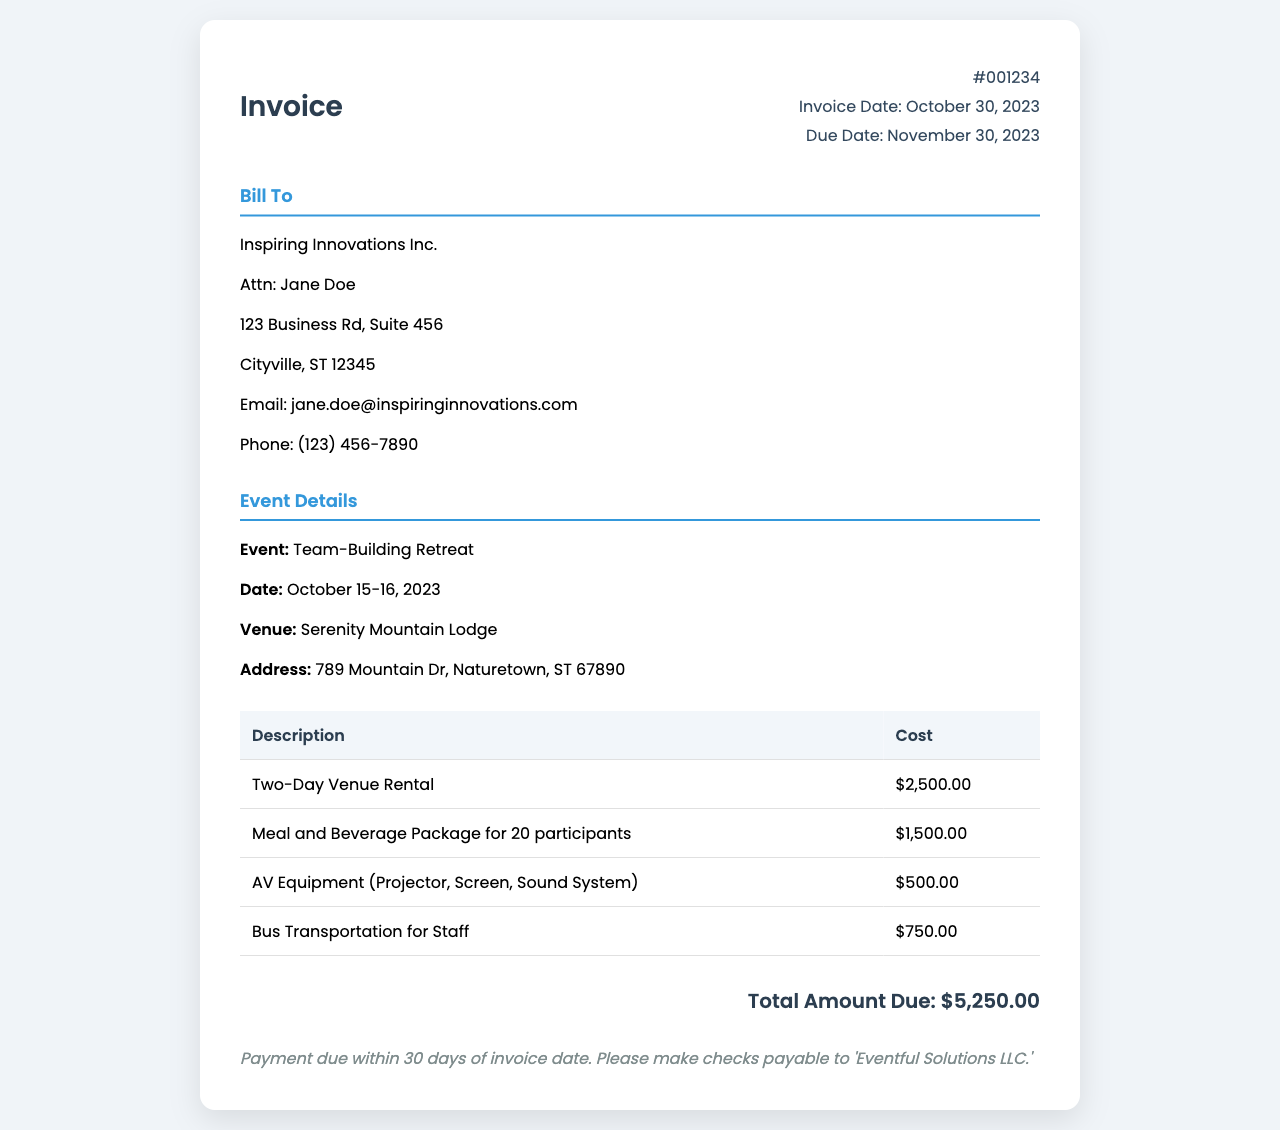what is the invoice number? The invoice number is listed at the top of the document under "Invoice Number."
Answer: #001234 who is the invoice billed to? The billing information includes the name of the company and contact person, found in the "Bill To" section.
Answer: Inspiring Innovations Inc what is the total amount due? The total amount due is prominently displayed at the bottom of the invoice.
Answer: $5,250.00 what are the dates of the event? The event dates are specified in the "Event Details" section.
Answer: October 15-16, 2023 where is the event venue located? The venue address is listed under "Event Details."
Answer: 789 Mountain Dr, Naturetown, ST 67890 how many participants were included in the catering package? The number of participants for the catering package is mentioned in the cost breakdown section.
Answer: 20 participants what is the due date for this invoice? The due date is stated in the invoice details section.
Answer: November 30, 2023 which company should checks be payable to? The company name for checks is found in the payment terms section of the document.
Answer: Eventful Solutions LLC how much was spent on bus transportation? The cost for bus transportation is included in the breakdown of expenses.
Answer: $750.00 